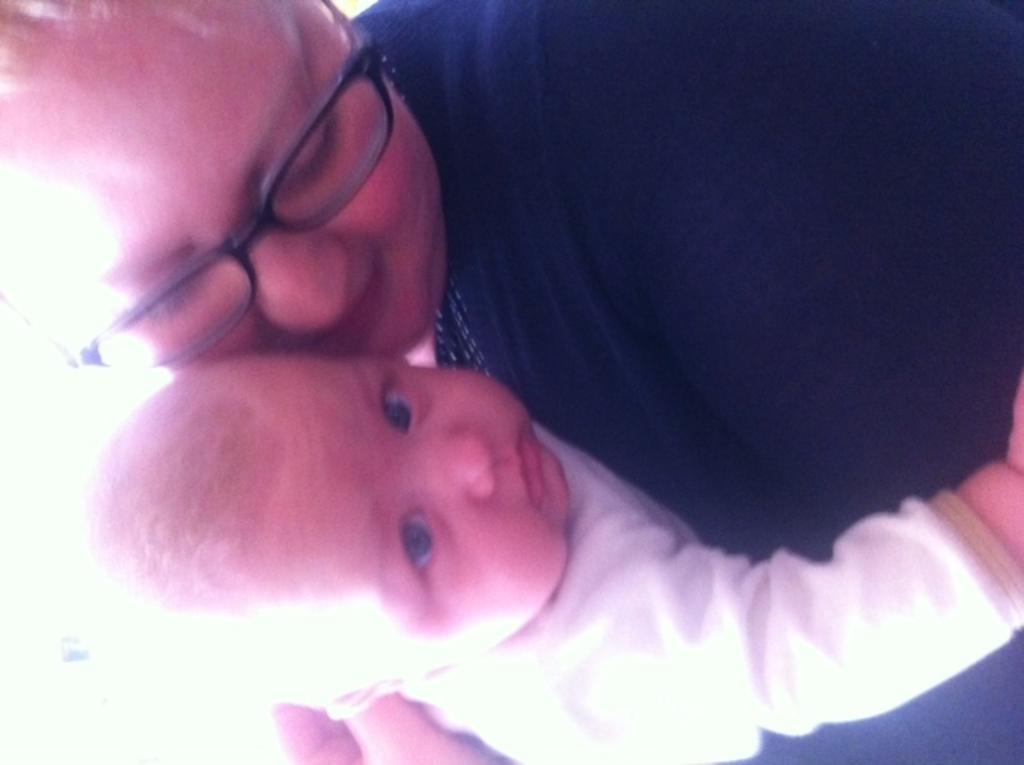Could you give a brief overview of what you see in this image? In this image there are two persons truncated, the person is wearing spectacles. 